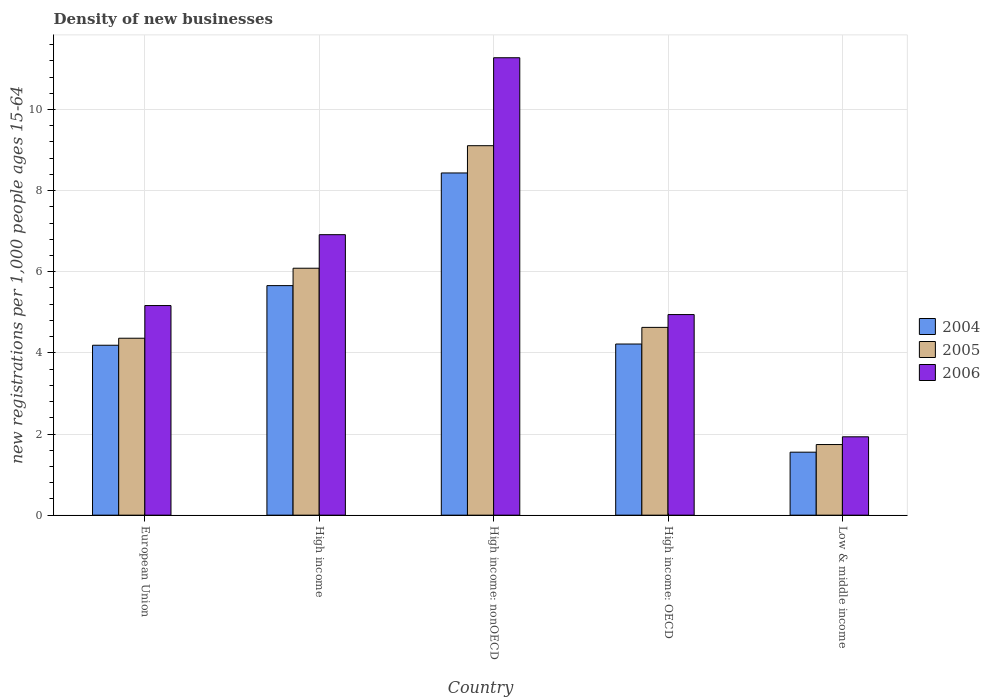Are the number of bars per tick equal to the number of legend labels?
Ensure brevity in your answer.  Yes. Are the number of bars on each tick of the X-axis equal?
Offer a very short reply. Yes. What is the label of the 4th group of bars from the left?
Offer a very short reply. High income: OECD. What is the number of new registrations in 2006 in High income?
Provide a short and direct response. 6.91. Across all countries, what is the maximum number of new registrations in 2004?
Your answer should be compact. 8.44. Across all countries, what is the minimum number of new registrations in 2005?
Your answer should be very brief. 1.74. In which country was the number of new registrations in 2006 maximum?
Ensure brevity in your answer.  High income: nonOECD. In which country was the number of new registrations in 2005 minimum?
Your answer should be compact. Low & middle income. What is the total number of new registrations in 2005 in the graph?
Give a very brief answer. 25.93. What is the difference between the number of new registrations in 2006 in High income: nonOECD and that in Low & middle income?
Provide a succinct answer. 9.34. What is the difference between the number of new registrations in 2005 in High income and the number of new registrations in 2004 in High income: OECD?
Your response must be concise. 1.87. What is the average number of new registrations in 2006 per country?
Offer a very short reply. 6.05. What is the difference between the number of new registrations of/in 2004 and number of new registrations of/in 2005 in High income?
Offer a terse response. -0.43. What is the ratio of the number of new registrations in 2005 in European Union to that in High income?
Your answer should be compact. 0.72. Is the number of new registrations in 2004 in European Union less than that in High income: nonOECD?
Make the answer very short. Yes. What is the difference between the highest and the second highest number of new registrations in 2006?
Keep it short and to the point. 6.11. What is the difference between the highest and the lowest number of new registrations in 2004?
Give a very brief answer. 6.88. Is the sum of the number of new registrations in 2006 in High income and High income: OECD greater than the maximum number of new registrations in 2004 across all countries?
Make the answer very short. Yes. What does the 1st bar from the left in Low & middle income represents?
Offer a very short reply. 2004. Is it the case that in every country, the sum of the number of new registrations in 2005 and number of new registrations in 2004 is greater than the number of new registrations in 2006?
Ensure brevity in your answer.  Yes. How many bars are there?
Offer a terse response. 15. How many countries are there in the graph?
Provide a short and direct response. 5. Does the graph contain grids?
Keep it short and to the point. Yes. What is the title of the graph?
Make the answer very short. Density of new businesses. Does "1978" appear as one of the legend labels in the graph?
Your answer should be compact. No. What is the label or title of the Y-axis?
Provide a succinct answer. New registrations per 1,0 people ages 15-64. What is the new registrations per 1,000 people ages 15-64 of 2004 in European Union?
Your answer should be very brief. 4.19. What is the new registrations per 1,000 people ages 15-64 in 2005 in European Union?
Keep it short and to the point. 4.36. What is the new registrations per 1,000 people ages 15-64 of 2006 in European Union?
Your answer should be compact. 5.17. What is the new registrations per 1,000 people ages 15-64 in 2004 in High income?
Offer a terse response. 5.66. What is the new registrations per 1,000 people ages 15-64 of 2005 in High income?
Your answer should be compact. 6.09. What is the new registrations per 1,000 people ages 15-64 of 2006 in High income?
Make the answer very short. 6.91. What is the new registrations per 1,000 people ages 15-64 of 2004 in High income: nonOECD?
Your answer should be very brief. 8.44. What is the new registrations per 1,000 people ages 15-64 in 2005 in High income: nonOECD?
Your answer should be compact. 9.11. What is the new registrations per 1,000 people ages 15-64 in 2006 in High income: nonOECD?
Offer a terse response. 11.28. What is the new registrations per 1,000 people ages 15-64 of 2004 in High income: OECD?
Your answer should be very brief. 4.22. What is the new registrations per 1,000 people ages 15-64 in 2005 in High income: OECD?
Your response must be concise. 4.63. What is the new registrations per 1,000 people ages 15-64 in 2006 in High income: OECD?
Your answer should be compact. 4.94. What is the new registrations per 1,000 people ages 15-64 in 2004 in Low & middle income?
Keep it short and to the point. 1.55. What is the new registrations per 1,000 people ages 15-64 in 2005 in Low & middle income?
Your answer should be very brief. 1.74. What is the new registrations per 1,000 people ages 15-64 of 2006 in Low & middle income?
Your answer should be compact. 1.93. Across all countries, what is the maximum new registrations per 1,000 people ages 15-64 of 2004?
Your answer should be compact. 8.44. Across all countries, what is the maximum new registrations per 1,000 people ages 15-64 in 2005?
Your response must be concise. 9.11. Across all countries, what is the maximum new registrations per 1,000 people ages 15-64 in 2006?
Provide a succinct answer. 11.28. Across all countries, what is the minimum new registrations per 1,000 people ages 15-64 in 2004?
Give a very brief answer. 1.55. Across all countries, what is the minimum new registrations per 1,000 people ages 15-64 of 2005?
Offer a terse response. 1.74. Across all countries, what is the minimum new registrations per 1,000 people ages 15-64 of 2006?
Provide a short and direct response. 1.93. What is the total new registrations per 1,000 people ages 15-64 of 2004 in the graph?
Make the answer very short. 24.06. What is the total new registrations per 1,000 people ages 15-64 of 2005 in the graph?
Provide a succinct answer. 25.93. What is the total new registrations per 1,000 people ages 15-64 in 2006 in the graph?
Provide a succinct answer. 30.23. What is the difference between the new registrations per 1,000 people ages 15-64 in 2004 in European Union and that in High income?
Ensure brevity in your answer.  -1.47. What is the difference between the new registrations per 1,000 people ages 15-64 in 2005 in European Union and that in High income?
Ensure brevity in your answer.  -1.73. What is the difference between the new registrations per 1,000 people ages 15-64 in 2006 in European Union and that in High income?
Ensure brevity in your answer.  -1.75. What is the difference between the new registrations per 1,000 people ages 15-64 of 2004 in European Union and that in High income: nonOECD?
Give a very brief answer. -4.25. What is the difference between the new registrations per 1,000 people ages 15-64 of 2005 in European Union and that in High income: nonOECD?
Offer a terse response. -4.75. What is the difference between the new registrations per 1,000 people ages 15-64 in 2006 in European Union and that in High income: nonOECD?
Your answer should be compact. -6.11. What is the difference between the new registrations per 1,000 people ages 15-64 in 2004 in European Union and that in High income: OECD?
Provide a succinct answer. -0.03. What is the difference between the new registrations per 1,000 people ages 15-64 of 2005 in European Union and that in High income: OECD?
Make the answer very short. -0.27. What is the difference between the new registrations per 1,000 people ages 15-64 in 2006 in European Union and that in High income: OECD?
Ensure brevity in your answer.  0.22. What is the difference between the new registrations per 1,000 people ages 15-64 in 2004 in European Union and that in Low & middle income?
Ensure brevity in your answer.  2.64. What is the difference between the new registrations per 1,000 people ages 15-64 of 2005 in European Union and that in Low & middle income?
Your answer should be very brief. 2.62. What is the difference between the new registrations per 1,000 people ages 15-64 in 2006 in European Union and that in Low & middle income?
Offer a very short reply. 3.24. What is the difference between the new registrations per 1,000 people ages 15-64 in 2004 in High income and that in High income: nonOECD?
Your response must be concise. -2.78. What is the difference between the new registrations per 1,000 people ages 15-64 of 2005 in High income and that in High income: nonOECD?
Your response must be concise. -3.02. What is the difference between the new registrations per 1,000 people ages 15-64 of 2006 in High income and that in High income: nonOECD?
Your answer should be compact. -4.36. What is the difference between the new registrations per 1,000 people ages 15-64 in 2004 in High income and that in High income: OECD?
Make the answer very short. 1.44. What is the difference between the new registrations per 1,000 people ages 15-64 in 2005 in High income and that in High income: OECD?
Make the answer very short. 1.46. What is the difference between the new registrations per 1,000 people ages 15-64 in 2006 in High income and that in High income: OECD?
Your response must be concise. 1.97. What is the difference between the new registrations per 1,000 people ages 15-64 of 2004 in High income and that in Low & middle income?
Provide a succinct answer. 4.11. What is the difference between the new registrations per 1,000 people ages 15-64 of 2005 in High income and that in Low & middle income?
Keep it short and to the point. 4.35. What is the difference between the new registrations per 1,000 people ages 15-64 in 2006 in High income and that in Low & middle income?
Ensure brevity in your answer.  4.98. What is the difference between the new registrations per 1,000 people ages 15-64 of 2004 in High income: nonOECD and that in High income: OECD?
Provide a short and direct response. 4.22. What is the difference between the new registrations per 1,000 people ages 15-64 of 2005 in High income: nonOECD and that in High income: OECD?
Provide a short and direct response. 4.48. What is the difference between the new registrations per 1,000 people ages 15-64 in 2006 in High income: nonOECD and that in High income: OECD?
Offer a terse response. 6.33. What is the difference between the new registrations per 1,000 people ages 15-64 in 2004 in High income: nonOECD and that in Low & middle income?
Give a very brief answer. 6.88. What is the difference between the new registrations per 1,000 people ages 15-64 of 2005 in High income: nonOECD and that in Low & middle income?
Offer a very short reply. 7.37. What is the difference between the new registrations per 1,000 people ages 15-64 of 2006 in High income: nonOECD and that in Low & middle income?
Keep it short and to the point. 9.34. What is the difference between the new registrations per 1,000 people ages 15-64 of 2004 in High income: OECD and that in Low & middle income?
Your answer should be very brief. 2.67. What is the difference between the new registrations per 1,000 people ages 15-64 of 2005 in High income: OECD and that in Low & middle income?
Make the answer very short. 2.89. What is the difference between the new registrations per 1,000 people ages 15-64 in 2006 in High income: OECD and that in Low & middle income?
Give a very brief answer. 3.01. What is the difference between the new registrations per 1,000 people ages 15-64 of 2004 in European Union and the new registrations per 1,000 people ages 15-64 of 2005 in High income?
Your response must be concise. -1.9. What is the difference between the new registrations per 1,000 people ages 15-64 of 2004 in European Union and the new registrations per 1,000 people ages 15-64 of 2006 in High income?
Provide a short and direct response. -2.73. What is the difference between the new registrations per 1,000 people ages 15-64 in 2005 in European Union and the new registrations per 1,000 people ages 15-64 in 2006 in High income?
Offer a very short reply. -2.55. What is the difference between the new registrations per 1,000 people ages 15-64 in 2004 in European Union and the new registrations per 1,000 people ages 15-64 in 2005 in High income: nonOECD?
Provide a succinct answer. -4.92. What is the difference between the new registrations per 1,000 people ages 15-64 in 2004 in European Union and the new registrations per 1,000 people ages 15-64 in 2006 in High income: nonOECD?
Keep it short and to the point. -7.09. What is the difference between the new registrations per 1,000 people ages 15-64 in 2005 in European Union and the new registrations per 1,000 people ages 15-64 in 2006 in High income: nonOECD?
Give a very brief answer. -6.91. What is the difference between the new registrations per 1,000 people ages 15-64 of 2004 in European Union and the new registrations per 1,000 people ages 15-64 of 2005 in High income: OECD?
Your answer should be compact. -0.44. What is the difference between the new registrations per 1,000 people ages 15-64 in 2004 in European Union and the new registrations per 1,000 people ages 15-64 in 2006 in High income: OECD?
Offer a terse response. -0.76. What is the difference between the new registrations per 1,000 people ages 15-64 of 2005 in European Union and the new registrations per 1,000 people ages 15-64 of 2006 in High income: OECD?
Offer a very short reply. -0.58. What is the difference between the new registrations per 1,000 people ages 15-64 in 2004 in European Union and the new registrations per 1,000 people ages 15-64 in 2005 in Low & middle income?
Keep it short and to the point. 2.45. What is the difference between the new registrations per 1,000 people ages 15-64 in 2004 in European Union and the new registrations per 1,000 people ages 15-64 in 2006 in Low & middle income?
Make the answer very short. 2.26. What is the difference between the new registrations per 1,000 people ages 15-64 in 2005 in European Union and the new registrations per 1,000 people ages 15-64 in 2006 in Low & middle income?
Offer a very short reply. 2.43. What is the difference between the new registrations per 1,000 people ages 15-64 of 2004 in High income and the new registrations per 1,000 people ages 15-64 of 2005 in High income: nonOECD?
Your answer should be compact. -3.45. What is the difference between the new registrations per 1,000 people ages 15-64 of 2004 in High income and the new registrations per 1,000 people ages 15-64 of 2006 in High income: nonOECD?
Your response must be concise. -5.62. What is the difference between the new registrations per 1,000 people ages 15-64 in 2005 in High income and the new registrations per 1,000 people ages 15-64 in 2006 in High income: nonOECD?
Your answer should be very brief. -5.19. What is the difference between the new registrations per 1,000 people ages 15-64 of 2004 in High income and the new registrations per 1,000 people ages 15-64 of 2005 in High income: OECD?
Provide a short and direct response. 1.03. What is the difference between the new registrations per 1,000 people ages 15-64 in 2004 in High income and the new registrations per 1,000 people ages 15-64 in 2006 in High income: OECD?
Offer a very short reply. 0.71. What is the difference between the new registrations per 1,000 people ages 15-64 of 2005 in High income and the new registrations per 1,000 people ages 15-64 of 2006 in High income: OECD?
Give a very brief answer. 1.14. What is the difference between the new registrations per 1,000 people ages 15-64 in 2004 in High income and the new registrations per 1,000 people ages 15-64 in 2005 in Low & middle income?
Give a very brief answer. 3.92. What is the difference between the new registrations per 1,000 people ages 15-64 of 2004 in High income and the new registrations per 1,000 people ages 15-64 of 2006 in Low & middle income?
Ensure brevity in your answer.  3.73. What is the difference between the new registrations per 1,000 people ages 15-64 in 2005 in High income and the new registrations per 1,000 people ages 15-64 in 2006 in Low & middle income?
Your answer should be compact. 4.16. What is the difference between the new registrations per 1,000 people ages 15-64 of 2004 in High income: nonOECD and the new registrations per 1,000 people ages 15-64 of 2005 in High income: OECD?
Ensure brevity in your answer.  3.81. What is the difference between the new registrations per 1,000 people ages 15-64 of 2004 in High income: nonOECD and the new registrations per 1,000 people ages 15-64 of 2006 in High income: OECD?
Your response must be concise. 3.49. What is the difference between the new registrations per 1,000 people ages 15-64 of 2005 in High income: nonOECD and the new registrations per 1,000 people ages 15-64 of 2006 in High income: OECD?
Ensure brevity in your answer.  4.16. What is the difference between the new registrations per 1,000 people ages 15-64 of 2004 in High income: nonOECD and the new registrations per 1,000 people ages 15-64 of 2005 in Low & middle income?
Offer a very short reply. 6.69. What is the difference between the new registrations per 1,000 people ages 15-64 of 2004 in High income: nonOECD and the new registrations per 1,000 people ages 15-64 of 2006 in Low & middle income?
Your answer should be very brief. 6.5. What is the difference between the new registrations per 1,000 people ages 15-64 in 2005 in High income: nonOECD and the new registrations per 1,000 people ages 15-64 in 2006 in Low & middle income?
Your response must be concise. 7.18. What is the difference between the new registrations per 1,000 people ages 15-64 in 2004 in High income: OECD and the new registrations per 1,000 people ages 15-64 in 2005 in Low & middle income?
Your answer should be very brief. 2.48. What is the difference between the new registrations per 1,000 people ages 15-64 of 2004 in High income: OECD and the new registrations per 1,000 people ages 15-64 of 2006 in Low & middle income?
Provide a succinct answer. 2.29. What is the difference between the new registrations per 1,000 people ages 15-64 in 2005 in High income: OECD and the new registrations per 1,000 people ages 15-64 in 2006 in Low & middle income?
Provide a succinct answer. 2.7. What is the average new registrations per 1,000 people ages 15-64 in 2004 per country?
Provide a short and direct response. 4.81. What is the average new registrations per 1,000 people ages 15-64 of 2005 per country?
Give a very brief answer. 5.19. What is the average new registrations per 1,000 people ages 15-64 of 2006 per country?
Make the answer very short. 6.05. What is the difference between the new registrations per 1,000 people ages 15-64 of 2004 and new registrations per 1,000 people ages 15-64 of 2005 in European Union?
Ensure brevity in your answer.  -0.17. What is the difference between the new registrations per 1,000 people ages 15-64 in 2004 and new registrations per 1,000 people ages 15-64 in 2006 in European Union?
Your answer should be very brief. -0.98. What is the difference between the new registrations per 1,000 people ages 15-64 of 2005 and new registrations per 1,000 people ages 15-64 of 2006 in European Union?
Offer a terse response. -0.81. What is the difference between the new registrations per 1,000 people ages 15-64 of 2004 and new registrations per 1,000 people ages 15-64 of 2005 in High income?
Your answer should be compact. -0.43. What is the difference between the new registrations per 1,000 people ages 15-64 in 2004 and new registrations per 1,000 people ages 15-64 in 2006 in High income?
Provide a short and direct response. -1.26. What is the difference between the new registrations per 1,000 people ages 15-64 of 2005 and new registrations per 1,000 people ages 15-64 of 2006 in High income?
Your answer should be compact. -0.83. What is the difference between the new registrations per 1,000 people ages 15-64 in 2004 and new registrations per 1,000 people ages 15-64 in 2005 in High income: nonOECD?
Offer a terse response. -0.67. What is the difference between the new registrations per 1,000 people ages 15-64 in 2004 and new registrations per 1,000 people ages 15-64 in 2006 in High income: nonOECD?
Keep it short and to the point. -2.84. What is the difference between the new registrations per 1,000 people ages 15-64 of 2005 and new registrations per 1,000 people ages 15-64 of 2006 in High income: nonOECD?
Keep it short and to the point. -2.17. What is the difference between the new registrations per 1,000 people ages 15-64 in 2004 and new registrations per 1,000 people ages 15-64 in 2005 in High income: OECD?
Ensure brevity in your answer.  -0.41. What is the difference between the new registrations per 1,000 people ages 15-64 of 2004 and new registrations per 1,000 people ages 15-64 of 2006 in High income: OECD?
Provide a succinct answer. -0.73. What is the difference between the new registrations per 1,000 people ages 15-64 in 2005 and new registrations per 1,000 people ages 15-64 in 2006 in High income: OECD?
Your response must be concise. -0.32. What is the difference between the new registrations per 1,000 people ages 15-64 in 2004 and new registrations per 1,000 people ages 15-64 in 2005 in Low & middle income?
Make the answer very short. -0.19. What is the difference between the new registrations per 1,000 people ages 15-64 in 2004 and new registrations per 1,000 people ages 15-64 in 2006 in Low & middle income?
Offer a terse response. -0.38. What is the difference between the new registrations per 1,000 people ages 15-64 in 2005 and new registrations per 1,000 people ages 15-64 in 2006 in Low & middle income?
Provide a succinct answer. -0.19. What is the ratio of the new registrations per 1,000 people ages 15-64 in 2004 in European Union to that in High income?
Make the answer very short. 0.74. What is the ratio of the new registrations per 1,000 people ages 15-64 of 2005 in European Union to that in High income?
Offer a terse response. 0.72. What is the ratio of the new registrations per 1,000 people ages 15-64 in 2006 in European Union to that in High income?
Provide a short and direct response. 0.75. What is the ratio of the new registrations per 1,000 people ages 15-64 in 2004 in European Union to that in High income: nonOECD?
Ensure brevity in your answer.  0.5. What is the ratio of the new registrations per 1,000 people ages 15-64 of 2005 in European Union to that in High income: nonOECD?
Offer a very short reply. 0.48. What is the ratio of the new registrations per 1,000 people ages 15-64 of 2006 in European Union to that in High income: nonOECD?
Keep it short and to the point. 0.46. What is the ratio of the new registrations per 1,000 people ages 15-64 in 2005 in European Union to that in High income: OECD?
Offer a terse response. 0.94. What is the ratio of the new registrations per 1,000 people ages 15-64 of 2006 in European Union to that in High income: OECD?
Your answer should be very brief. 1.04. What is the ratio of the new registrations per 1,000 people ages 15-64 in 2004 in European Union to that in Low & middle income?
Keep it short and to the point. 2.7. What is the ratio of the new registrations per 1,000 people ages 15-64 in 2005 in European Union to that in Low & middle income?
Ensure brevity in your answer.  2.51. What is the ratio of the new registrations per 1,000 people ages 15-64 of 2006 in European Union to that in Low & middle income?
Ensure brevity in your answer.  2.68. What is the ratio of the new registrations per 1,000 people ages 15-64 of 2004 in High income to that in High income: nonOECD?
Make the answer very short. 0.67. What is the ratio of the new registrations per 1,000 people ages 15-64 of 2005 in High income to that in High income: nonOECD?
Make the answer very short. 0.67. What is the ratio of the new registrations per 1,000 people ages 15-64 of 2006 in High income to that in High income: nonOECD?
Your answer should be compact. 0.61. What is the ratio of the new registrations per 1,000 people ages 15-64 of 2004 in High income to that in High income: OECD?
Offer a very short reply. 1.34. What is the ratio of the new registrations per 1,000 people ages 15-64 in 2005 in High income to that in High income: OECD?
Keep it short and to the point. 1.31. What is the ratio of the new registrations per 1,000 people ages 15-64 of 2006 in High income to that in High income: OECD?
Your response must be concise. 1.4. What is the ratio of the new registrations per 1,000 people ages 15-64 of 2004 in High income to that in Low & middle income?
Make the answer very short. 3.64. What is the ratio of the new registrations per 1,000 people ages 15-64 in 2005 in High income to that in Low & middle income?
Your answer should be very brief. 3.5. What is the ratio of the new registrations per 1,000 people ages 15-64 of 2006 in High income to that in Low & middle income?
Your answer should be very brief. 3.58. What is the ratio of the new registrations per 1,000 people ages 15-64 in 2004 in High income: nonOECD to that in High income: OECD?
Provide a succinct answer. 2. What is the ratio of the new registrations per 1,000 people ages 15-64 in 2005 in High income: nonOECD to that in High income: OECD?
Offer a terse response. 1.97. What is the ratio of the new registrations per 1,000 people ages 15-64 in 2006 in High income: nonOECD to that in High income: OECD?
Your answer should be very brief. 2.28. What is the ratio of the new registrations per 1,000 people ages 15-64 in 2004 in High income: nonOECD to that in Low & middle income?
Your answer should be very brief. 5.43. What is the ratio of the new registrations per 1,000 people ages 15-64 in 2005 in High income: nonOECD to that in Low & middle income?
Make the answer very short. 5.23. What is the ratio of the new registrations per 1,000 people ages 15-64 of 2006 in High income: nonOECD to that in Low & middle income?
Provide a short and direct response. 5.84. What is the ratio of the new registrations per 1,000 people ages 15-64 in 2004 in High income: OECD to that in Low & middle income?
Your response must be concise. 2.72. What is the ratio of the new registrations per 1,000 people ages 15-64 of 2005 in High income: OECD to that in Low & middle income?
Your answer should be compact. 2.66. What is the ratio of the new registrations per 1,000 people ages 15-64 of 2006 in High income: OECD to that in Low & middle income?
Your response must be concise. 2.56. What is the difference between the highest and the second highest new registrations per 1,000 people ages 15-64 of 2004?
Keep it short and to the point. 2.78. What is the difference between the highest and the second highest new registrations per 1,000 people ages 15-64 in 2005?
Offer a very short reply. 3.02. What is the difference between the highest and the second highest new registrations per 1,000 people ages 15-64 in 2006?
Offer a very short reply. 4.36. What is the difference between the highest and the lowest new registrations per 1,000 people ages 15-64 in 2004?
Offer a very short reply. 6.88. What is the difference between the highest and the lowest new registrations per 1,000 people ages 15-64 in 2005?
Keep it short and to the point. 7.37. What is the difference between the highest and the lowest new registrations per 1,000 people ages 15-64 in 2006?
Your answer should be compact. 9.34. 